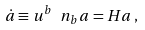<formula> <loc_0><loc_0><loc_500><loc_500>\dot { a } \equiv u ^ { b } \ n _ { b } a = H a \, ,</formula> 